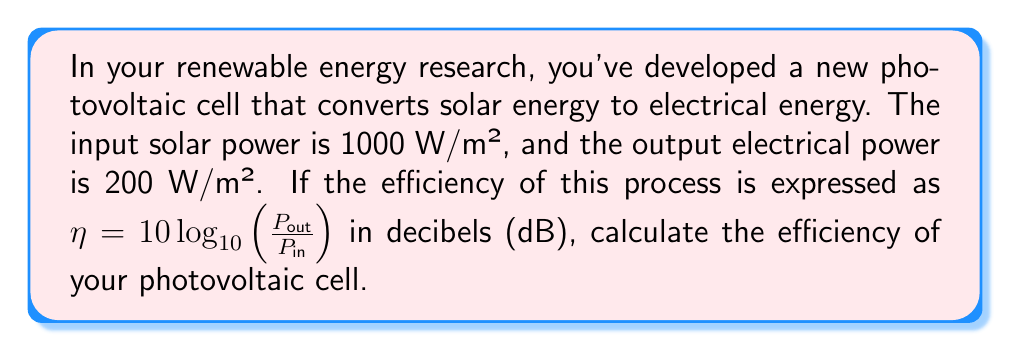Give your solution to this math problem. To solve this problem, we'll follow these steps:

1) We're given the formula for efficiency:
   $$\eta = 10 \log_{10}(\frac{P_{out}}{P_{in}})$$

2) We know:
   $P_{in} = 1000 \text{ W/m²}$
   $P_{out} = 200 \text{ W/m²}$

3) Let's substitute these values into the formula:
   $$\eta = 10 \log_{10}(\frac{200}{1000})$$

4) Simplify the fraction inside the logarithm:
   $$\eta = 10 \log_{10}(0.2)$$

5) Calculate the logarithm:
   $\log_{10}(0.2) \approx -0.69897$

6) Multiply by 10:
   $$\eta = 10 \times (-0.69897) \approx -6.9897$$

7) Round to two decimal places:
   $$\eta \approx -7.00 \text{ dB}$$

The negative value indicates that the output power is less than the input power, which is expected in any real-world energy conversion process.
Answer: $-7.00 \text{ dB}$ 